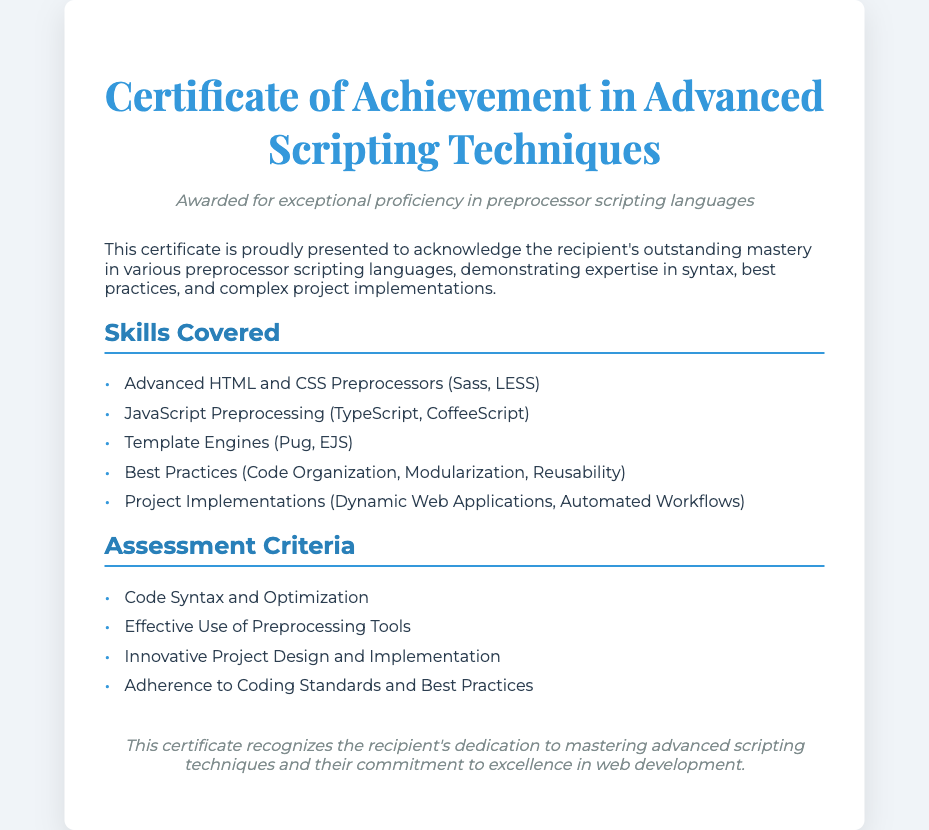What is the title of the diploma? The title is prominently displayed at the top of the document.
Answer: Certificate of Achievement in Advanced Scripting Techniques Who is the certificate awarded to? The document states that it is presented to acknowledge the recipient's mastery.
Answer: Recipient What skills are covered in the diploma? The skills are listed under the "Skills Covered" section.
Answer: Advanced HTML and CSS Preprocessors (Sass, LESS) What are the assessment criteria mentioned? The assessment criteria are outlined in a specific section of the document.
Answer: Code Syntax and Optimization What is the color theme of the document? The document uses specific colors that are indicated in the design sections.
Answer: Blue and white What does the subtitle emphasize? The subtitle describes the focus of the award in one phrase.
Answer: Exceptional proficiency in preprocessor scripting languages How many main sections are there in the content? The document is organized into clear segments, specifically.
Answer: Two What best practices are highlighted? Best practices are mentioned in the skills section.
Answer: Code Organization, Modularization, Reusability What does the footer acknowledge? The footer includes a statement on the recipient's dedication mentioned.
Answer: Mastering advanced scripting techniques 